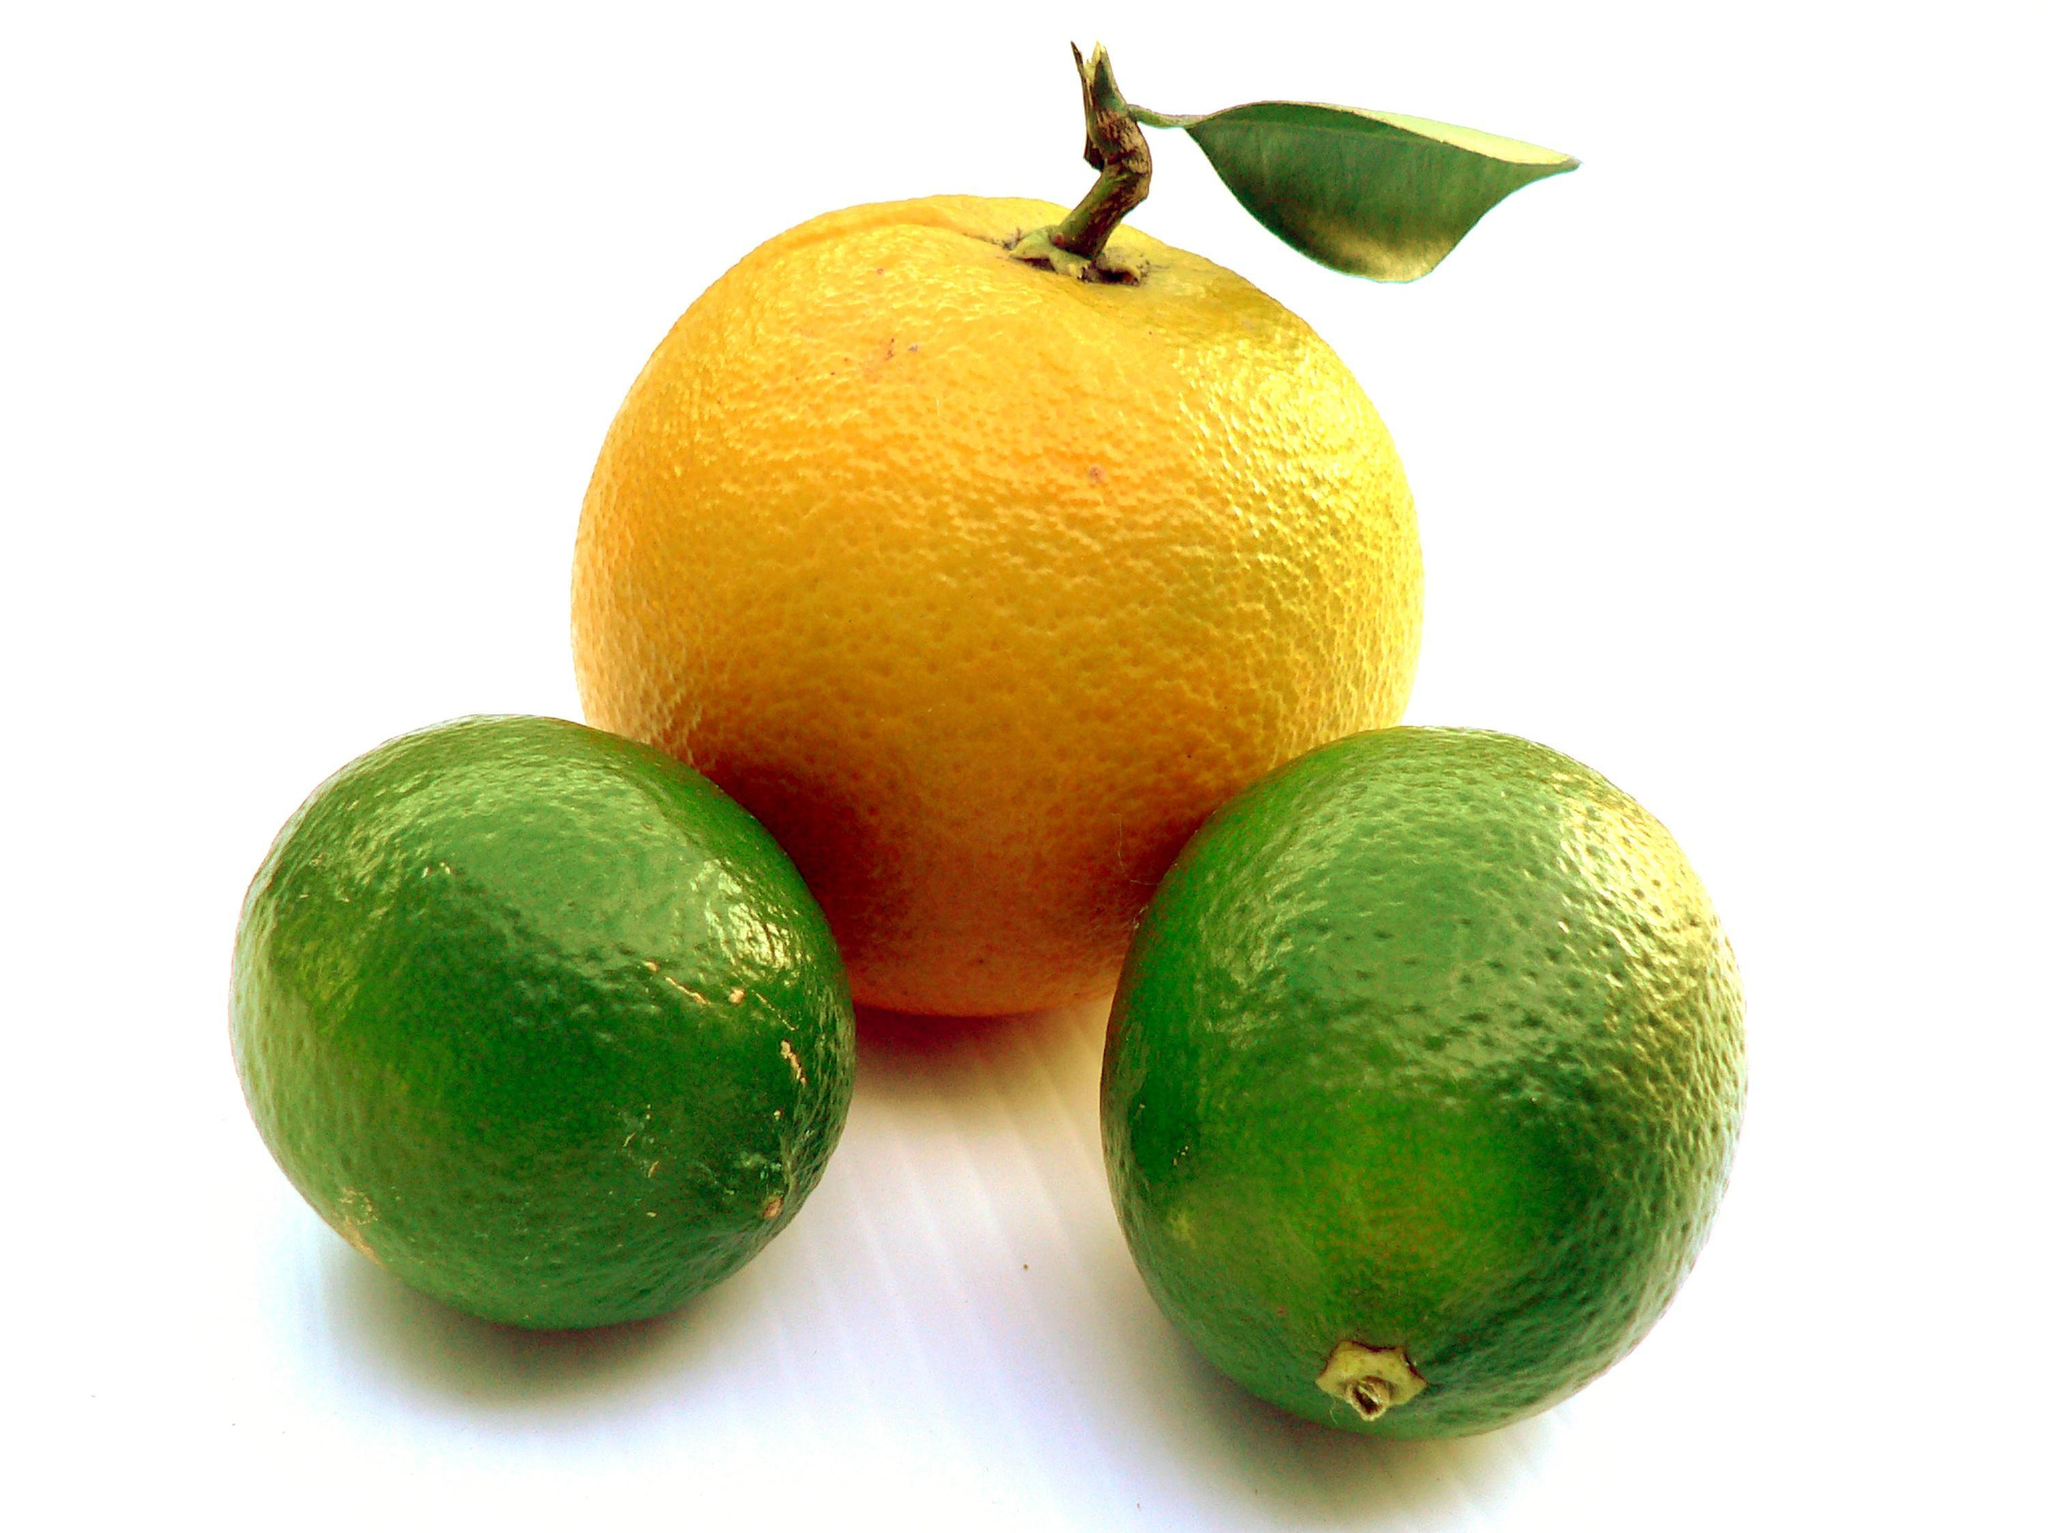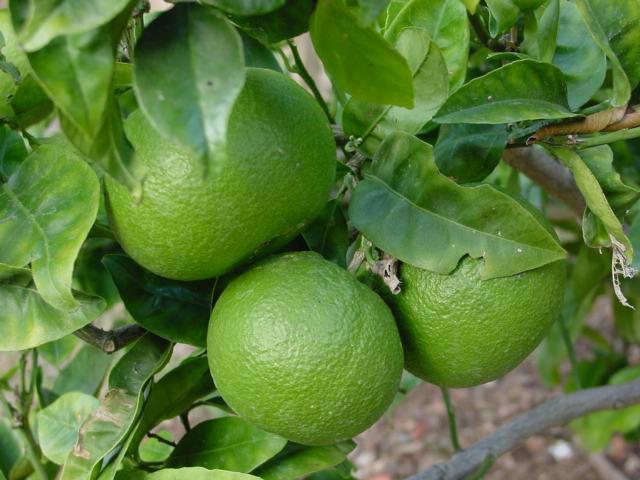The first image is the image on the left, the second image is the image on the right. For the images shown, is this caption "In one of the images there are at least three oranges still attached to the tree." true? Answer yes or no. Yes. 